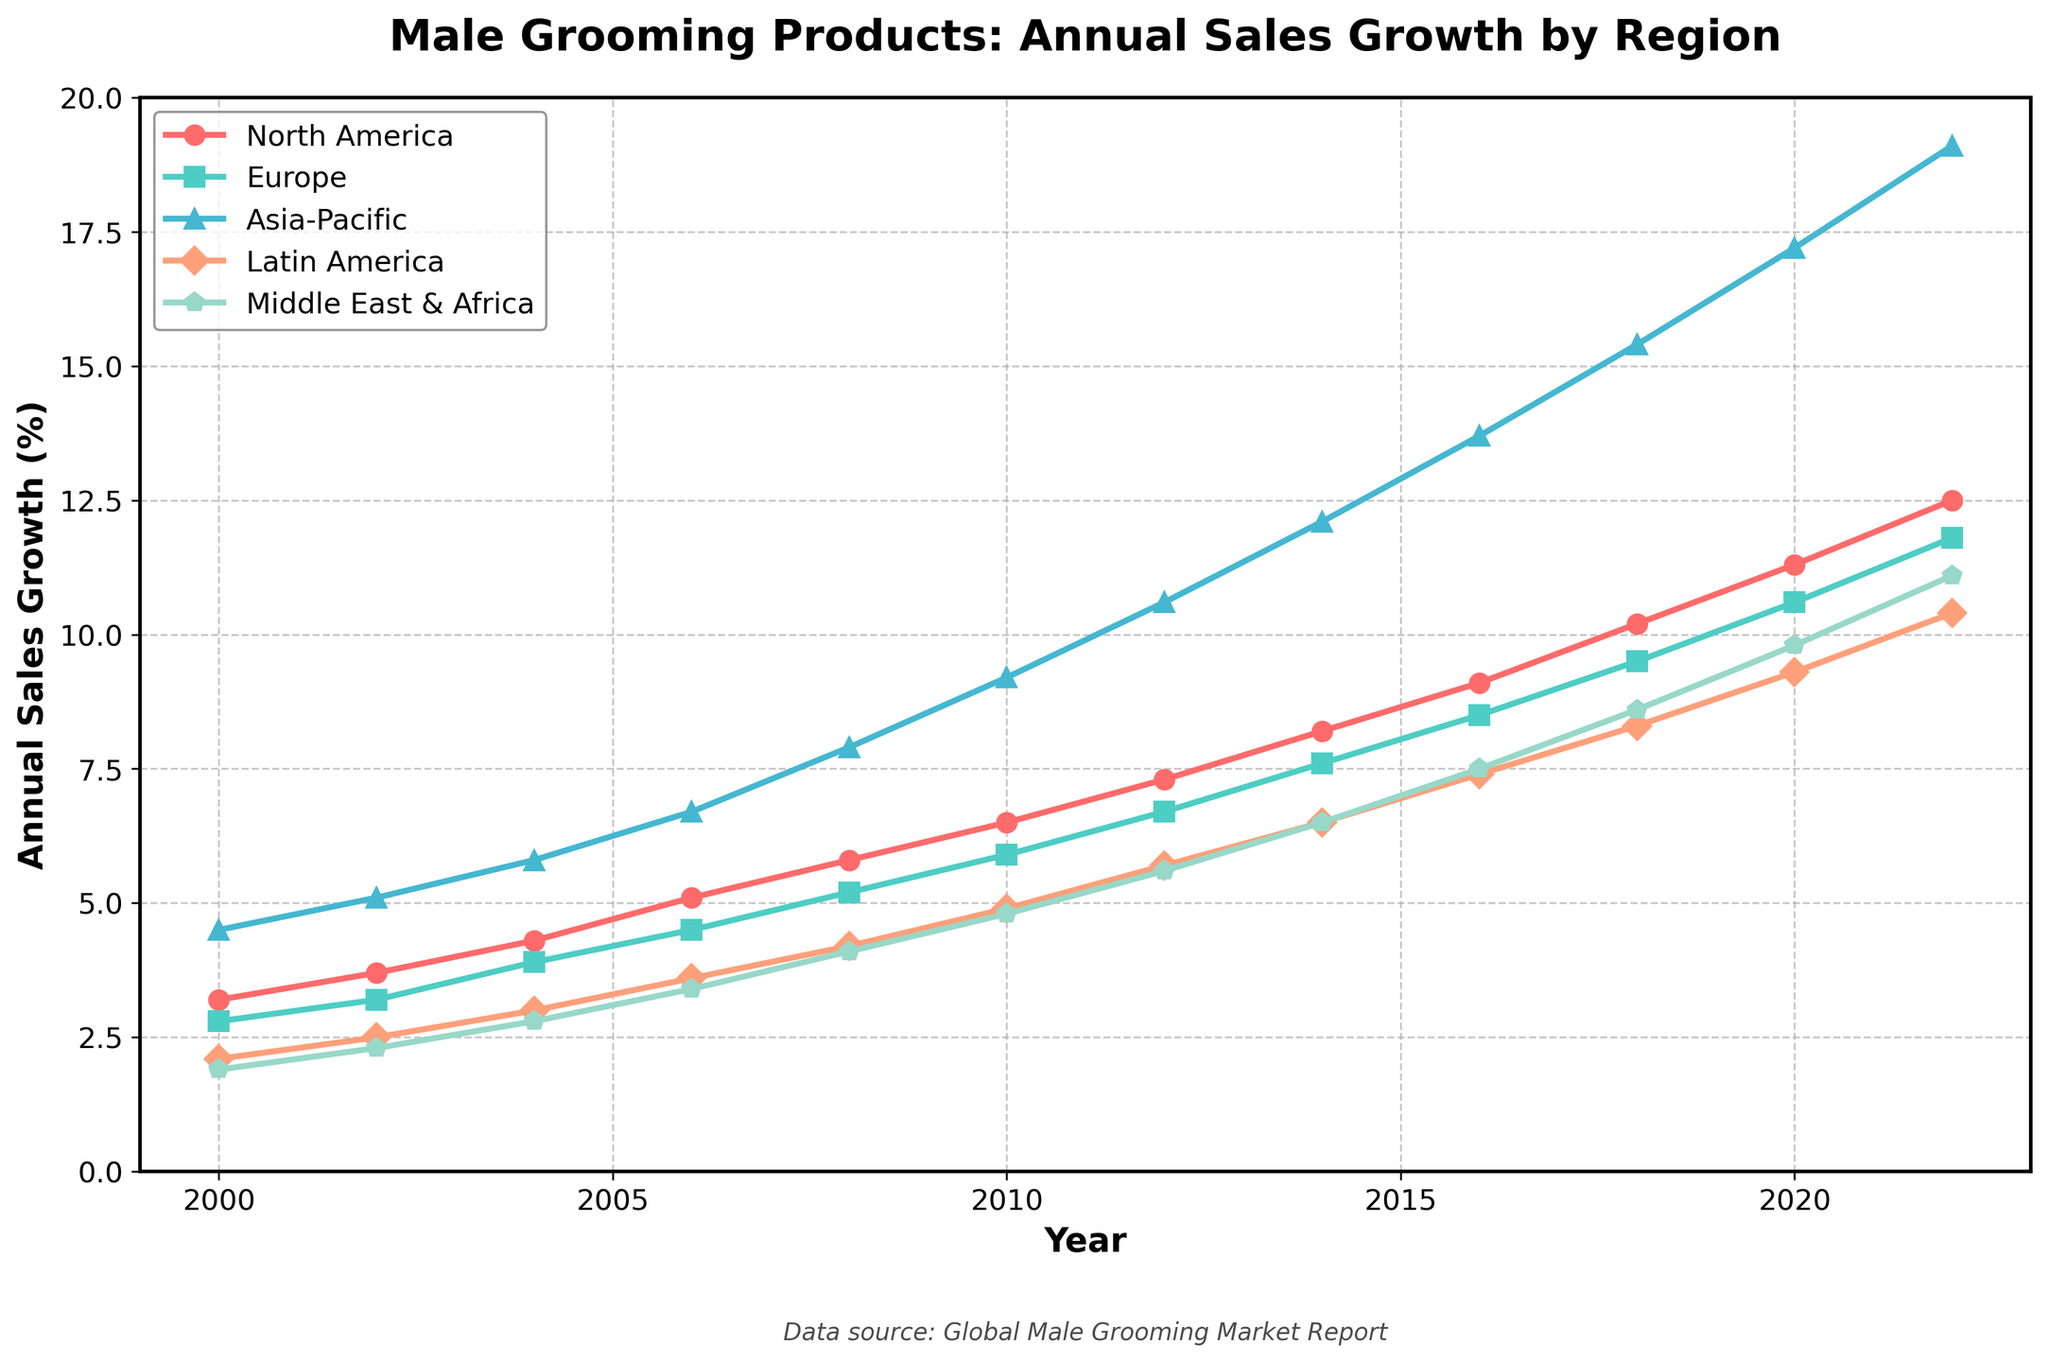What's the annual sales growth rate for male grooming products in North America in 2010? Locate the "North America" line in the chart and find the year 2010. The corresponding point for 2010 shows the sales growth rate.
Answer: 6.5% How did the sales growth rate for male grooming products in the Asia-Pacific region change from 2000 to 2022? Identify the points for the Asia-Pacific region in 2000 and 2022 and note their values. Subtract the value in 2000 from the value in 2022 to find the change.
Answer: 14.6% Which region had the highest annual sales growth rate for male grooming products in 2022? Look at the points for all regions in the year 2022 and compare their values. The region with the highest value has the highest growth rate.
Answer: Asia-Pacific Between which years did the Middle East & Africa experience the most significant increase in sales growth for male grooming products? Identify the data points for the Middle East & Africa across different years and find the two consecutive years where the difference between their values is the greatest.
Answer: 2010 to 2012 What is the difference in the sales growth rate of male grooming products between North America and Europe in 2018? Find the data points for North America and Europe in 2018 and subtract the value of Europe from North America.
Answer: 0.7% In which year did Latin America surpass a 5% annual sales growth rate? Observe the trajectory of the Latin America line and identify the first year where its value exceeds 5%.
Answer: 2012 Calculate the average annual sales growth rate for male grooming products in Europe from 2000 to 2010. Sum the values for Europe from 2000 to 2010 (inclusive) and divide by the number of years (6). The years and corresponding values are 2000 (2.8), 2002 (3.2), 2004 (3.9), 2006 (4.5), 2008 (5.2), and 2010 (5.9). The total is (2.8 + 3.2 + 3.9 + 4.5 + 5.2 + 5.9) = 25.5. The average is 25.5 / 6 = 4.25.
Answer: 4.25% For which region does the trend line show the most steady increase in sales growth rate over time? Examine the general slopes of all lines over the period from 2000 to 2022. Determine which line has the smoothest, most consistent increase without large fluctuations.
Answer: Asia-Pacific How many regions had an annual sales growth rate above 10% in 2020? Check the values for all regions in 2020 and count how many of them are above 10%. The regions and corresponding values are North America (11.3), Europe (10.6), Asia-Pacific (17.2), Latin America (9.3), Middle East & Africa (9.8).
Answer: 3 What is the compound annual growth rate (CAGR) for male grooming products in Latin America from 2000 to 2022? The CAGR can be found using the formula \( CAGR = \left(\frac{ending\ value}{beginning\ value}\right)^\frac{1}{number\ of\ periods} - 1 \). For Latin America, the beginning value in 2000 is 2.1, the ending value in 2022 is 10.4, and the number of periods is 22 years. \( CAGR = \left(\frac{10.4}{2.1}\right)^\frac{1}{22} - 1 \approx 0.0714 \), or 7.14%.
Answer: 7.14% 